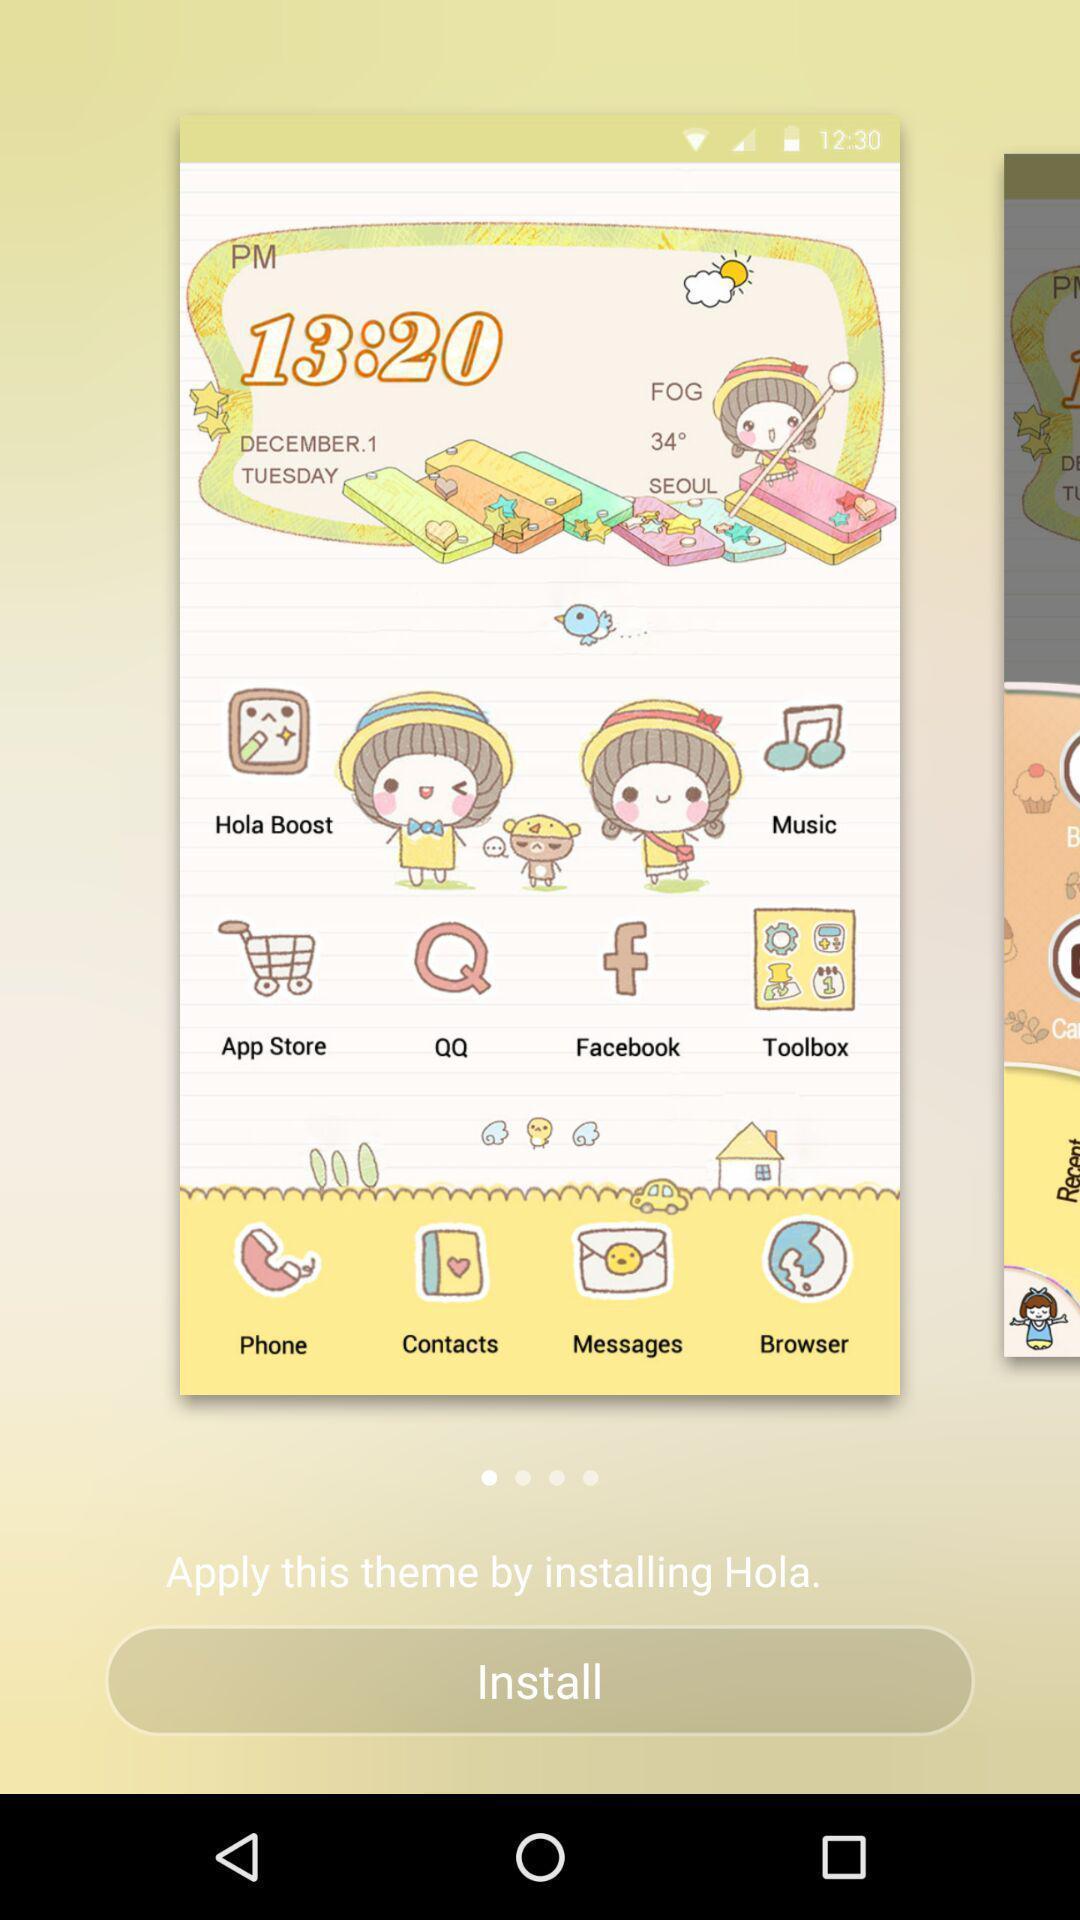Provide a textual representation of this image. Theme installing page on the screen. 